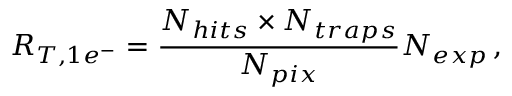Convert formula to latex. <formula><loc_0><loc_0><loc_500><loc_500>R _ { T , 1 e ^ { - } } = \frac { N _ { h i t s } \times N _ { t r a p s } } { N _ { p i x } } N _ { e x p } \, ,</formula> 